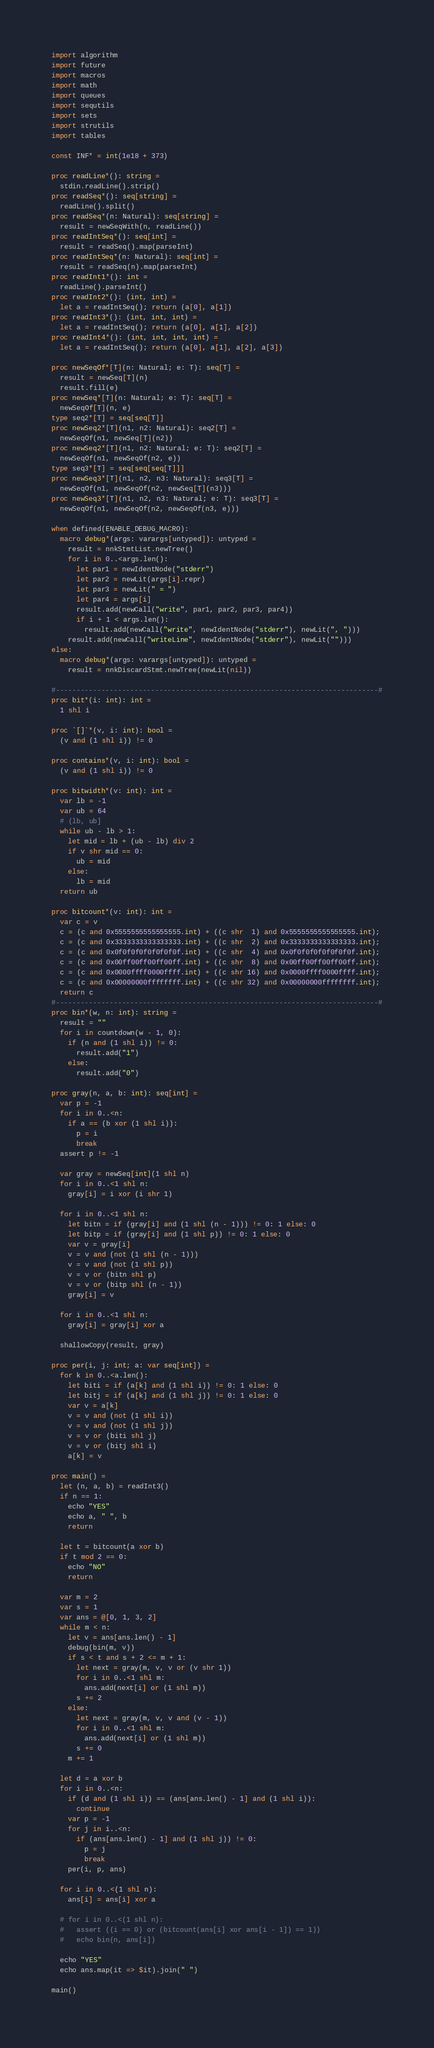Convert code to text. <code><loc_0><loc_0><loc_500><loc_500><_Nim_>import algorithm
import future
import macros
import math
import queues
import sequtils
import sets
import strutils
import tables

const INF* = int(1e18 + 373)

proc readLine*(): string =
  stdin.readLine().strip()
proc readSeq*(): seq[string] =
  readLine().split()
proc readSeq*(n: Natural): seq[string] =
  result = newSeqWith(n, readLine())
proc readIntSeq*(): seq[int] =
  result = readSeq().map(parseInt)
proc readIntSeq*(n: Natural): seq[int] =
  result = readSeq(n).map(parseInt)
proc readInt1*(): int =
  readLine().parseInt()
proc readInt2*(): (int, int) =
  let a = readIntSeq(); return (a[0], a[1])
proc readInt3*(): (int, int, int) =
  let a = readIntSeq(); return (a[0], a[1], a[2])
proc readInt4*(): (int, int, int, int) =
  let a = readIntSeq(); return (a[0], a[1], a[2], a[3])

proc newSeqOf*[T](n: Natural; e: T): seq[T] =
  result = newSeq[T](n)
  result.fill(e)
proc newSeq*[T](n: Natural; e: T): seq[T] =
  newSeqOf[T](n, e)
type seq2*[T] = seq[seq[T]]
proc newSeq2*[T](n1, n2: Natural): seq2[T] =
  newSeqOf(n1, newSeq[T](n2))
proc newSeq2*[T](n1, n2: Natural; e: T): seq2[T] =
  newSeqOf(n1, newSeqOf(n2, e))
type seq3*[T] = seq[seq[seq[T]]]
proc newSeq3*[T](n1, n2, n3: Natural): seq3[T] =
  newSeqOf(n1, newSeqOf(n2, newSeq[T](n3)))
proc newSeq3*[T](n1, n2, n3: Natural; e: T): seq3[T] =
  newSeqOf(n1, newSeqOf(n2, newSeqOf(n3, e)))

when defined(ENABLE_DEBUG_MACRO):
  macro debug*(args: varargs[untyped]): untyped =
    result = nnkStmtList.newTree()
    for i in 0..<args.len():
      let par1 = newIdentNode("stderr")
      let par2 = newLit(args[i].repr)
      let par3 = newLit(" = ")
      let par4 = args[i]
      result.add(newCall("write", par1, par2, par3, par4))
      if i + 1 < args.len():
        result.add(newCall("write", newIdentNode("stderr"), newLit(", ")))
    result.add(newCall("writeLine", newIdentNode("stderr"), newLit("")))
else:
  macro debug*(args: varargs[untyped]): untyped =
    result = nnkDiscardStmt.newTree(newLit(nil))

#------------------------------------------------------------------------------#
proc bit*(i: int): int =
  1 shl i

proc `[]`*(v, i: int): bool =
  (v and (1 shl i)) != 0

proc contains*(v, i: int): bool =
  (v and (1 shl i)) != 0

proc bitwidth*(v: int): int =
  var lb = -1
  var ub = 64
  # (lb, ub]
  while ub - lb > 1:
    let mid = lb + (ub - lb) div 2
    if v shr mid == 0:
      ub = mid
    else:
      lb = mid
  return ub

proc bitcount*(v: int): int =
  var c = v
  c = (c and 0x5555555555555555.int) + ((c shr  1) and 0x5555555555555555.int);
  c = (c and 0x3333333333333333.int) + ((c shr  2) and 0x3333333333333333.int);
  c = (c and 0x0f0f0f0f0f0f0f0f.int) + ((c shr  4) and 0x0f0f0f0f0f0f0f0f.int);
  c = (c and 0x00ff00ff00ff00ff.int) + ((c shr  8) and 0x00ff00ff00ff00ff.int);
  c = (c and 0x0000ffff0000ffff.int) + ((c shr 16) and 0x0000ffff0000ffff.int);
  c = (c and 0x00000000ffffffff.int) + ((c shr 32) and 0x00000000ffffffff.int);
  return c
#------------------------------------------------------------------------------#
proc bin*(w, n: int): string =
  result = ""
  for i in countdown(w - 1, 0):
    if (n and (1 shl i)) != 0:
      result.add("1")
    else:
      result.add("0")

proc gray(n, a, b: int): seq[int] =
  var p = -1
  for i in 0..<n:
    if a == (b xor (1 shl i)):
      p = i
      break
  assert p != -1

  var gray = newSeq[int](1 shl n)
  for i in 0..<1 shl n:
    gray[i] = i xor (i shr 1)

  for i in 0..<1 shl n:
    let bitn = if (gray[i] and (1 shl (n - 1))) != 0: 1 else: 0
    let bitp = if (gray[i] and (1 shl p)) != 0: 1 else: 0
    var v = gray[i]
    v = v and (not (1 shl (n - 1)))
    v = v and (not (1 shl p))
    v = v or (bitn shl p)
    v = v or (bitp shl (n - 1))
    gray[i] = v

  for i in 0..<1 shl n:
    gray[i] = gray[i] xor a

  shallowCopy(result, gray)

proc per(i, j: int; a: var seq[int]) =
  for k in 0..<a.len():
    let biti = if (a[k] and (1 shl i)) != 0: 1 else: 0
    let bitj = if (a[k] and (1 shl j)) != 0: 1 else: 0
    var v = a[k]
    v = v and (not (1 shl i))
    v = v and (not (1 shl j))
    v = v or (biti shl j)
    v = v or (bitj shl i)
    a[k] = v

proc main() =
  let (n, a, b) = readInt3()
  if n == 1:
    echo "YES"
    echo a, " ", b
    return

  let t = bitcount(a xor b)
  if t mod 2 == 0:
    echo "NO"
    return

  var m = 2
  var s = 1
  var ans = @[0, 1, 3, 2]
  while m < n:
    let v = ans[ans.len() - 1]
    debug(bin(m, v))
    if s < t and s + 2 <= m + 1:
      let next = gray(m, v, v or (v shr 1))
      for i in 0..<1 shl m:
        ans.add(next[i] or (1 shl m))
      s += 2
    else:
      let next = gray(m, v, v and (v - 1))
      for i in 0..<1 shl m:
        ans.add(next[i] or (1 shl m))
      s += 0
    m += 1

  let d = a xor b
  for i in 0..<n:
    if (d and (1 shl i)) == (ans[ans.len() - 1] and (1 shl i)):
      continue
    var p = -1
    for j in i..<n:
      if (ans[ans.len() - 1] and (1 shl j)) != 0:
        p = j
        break
    per(i, p, ans)

  for i in 0..<(1 shl n):
    ans[i] = ans[i] xor a

  # for i in 0..<(1 shl n):
  #   assert ((i == 0) or (bitcount(ans[i] xor ans[i - 1]) == 1))
  #   echo bin(n, ans[i])

  echo "YES"
  echo ans.map(it => $it).join(" ")

main()
</code> 